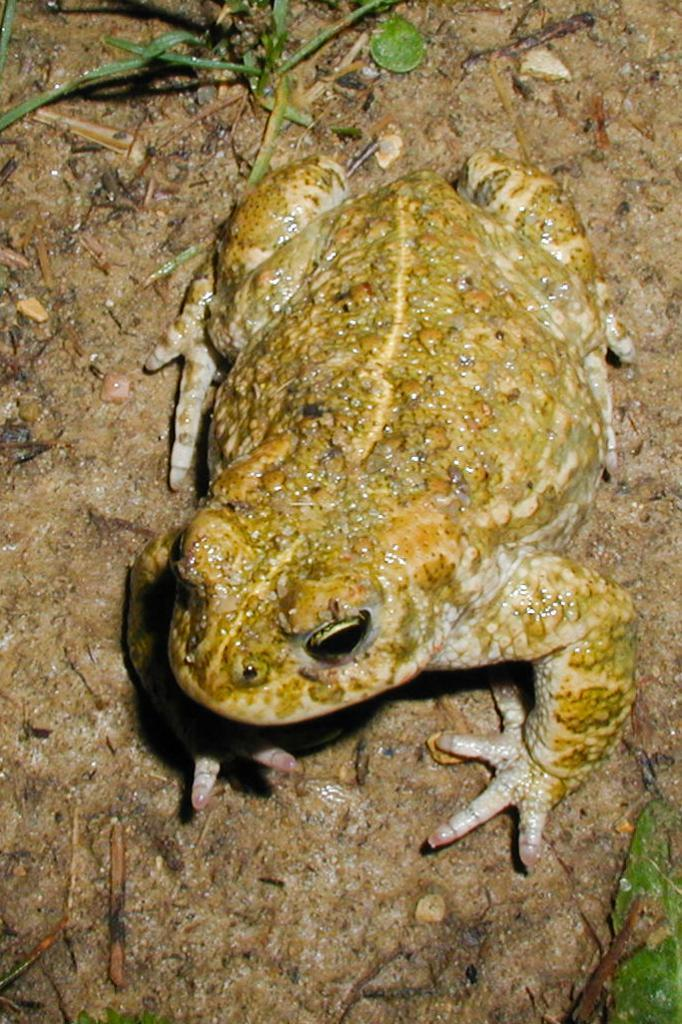What animal is present in the picture? There is a frog in the picture. What type of vegetation can be seen in the picture? There is grass visible in the picture. Where is the leaf located in the picture? The leaf is in the bottom right corner of the picture. What type of toothpaste is the frog using in the picture? There is no toothpaste present in the picture, and the frog is not using any toothpaste. 